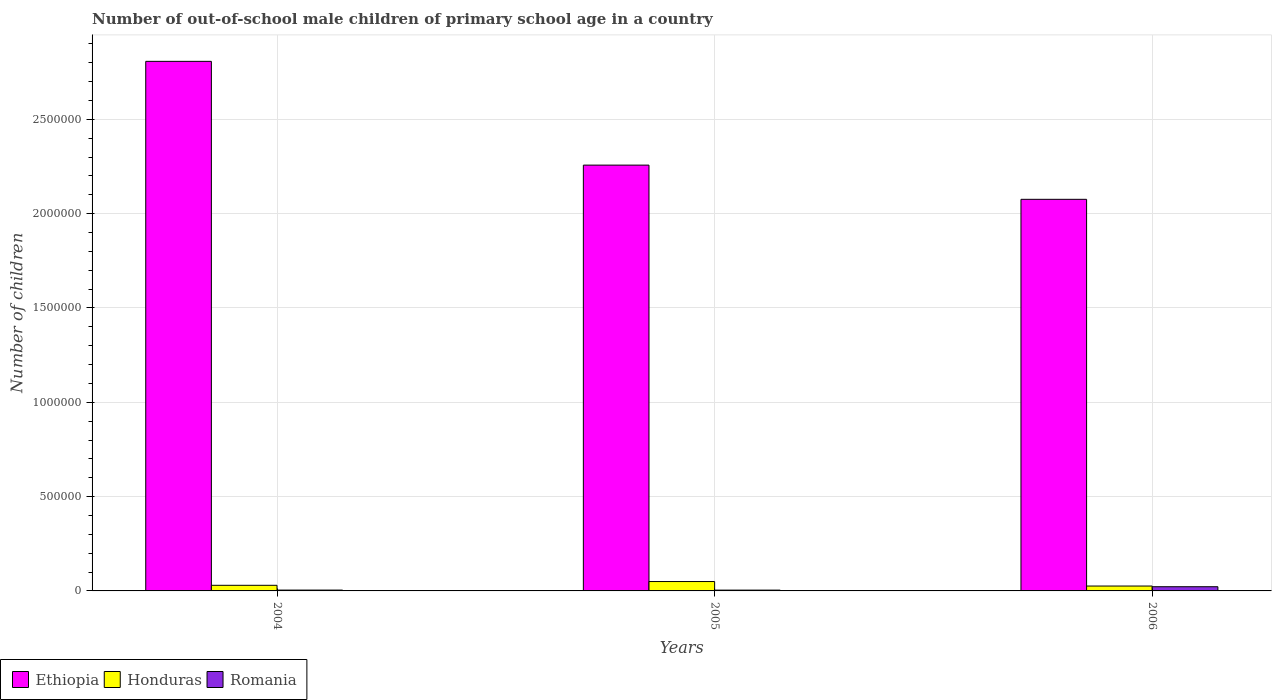How many different coloured bars are there?
Your answer should be compact. 3. Are the number of bars per tick equal to the number of legend labels?
Your answer should be compact. Yes. Are the number of bars on each tick of the X-axis equal?
Your answer should be very brief. Yes. How many bars are there on the 3rd tick from the left?
Provide a short and direct response. 3. How many bars are there on the 1st tick from the right?
Your response must be concise. 3. In how many cases, is the number of bars for a given year not equal to the number of legend labels?
Make the answer very short. 0. What is the number of out-of-school male children in Romania in 2005?
Give a very brief answer. 4225. Across all years, what is the maximum number of out-of-school male children in Honduras?
Make the answer very short. 4.97e+04. Across all years, what is the minimum number of out-of-school male children in Romania?
Your answer should be compact. 4225. In which year was the number of out-of-school male children in Honduras maximum?
Give a very brief answer. 2005. What is the total number of out-of-school male children in Ethiopia in the graph?
Provide a short and direct response. 7.14e+06. What is the difference between the number of out-of-school male children in Ethiopia in 2004 and that in 2006?
Make the answer very short. 7.31e+05. What is the difference between the number of out-of-school male children in Romania in 2005 and the number of out-of-school male children in Ethiopia in 2004?
Provide a short and direct response. -2.80e+06. What is the average number of out-of-school male children in Romania per year?
Give a very brief answer. 1.03e+04. In the year 2006, what is the difference between the number of out-of-school male children in Romania and number of out-of-school male children in Ethiopia?
Give a very brief answer. -2.05e+06. In how many years, is the number of out-of-school male children in Honduras greater than 700000?
Ensure brevity in your answer.  0. What is the ratio of the number of out-of-school male children in Ethiopia in 2004 to that in 2005?
Ensure brevity in your answer.  1.24. Is the number of out-of-school male children in Romania in 2004 less than that in 2005?
Your answer should be compact. No. What is the difference between the highest and the second highest number of out-of-school male children in Honduras?
Offer a very short reply. 1.99e+04. What is the difference between the highest and the lowest number of out-of-school male children in Romania?
Make the answer very short. 1.80e+04. In how many years, is the number of out-of-school male children in Ethiopia greater than the average number of out-of-school male children in Ethiopia taken over all years?
Keep it short and to the point. 1. Is the sum of the number of out-of-school male children in Ethiopia in 2004 and 2006 greater than the maximum number of out-of-school male children in Honduras across all years?
Keep it short and to the point. Yes. What does the 3rd bar from the left in 2004 represents?
Keep it short and to the point. Romania. What does the 2nd bar from the right in 2004 represents?
Give a very brief answer. Honduras. How many bars are there?
Make the answer very short. 9. How many years are there in the graph?
Give a very brief answer. 3. What is the difference between two consecutive major ticks on the Y-axis?
Offer a very short reply. 5.00e+05. Are the values on the major ticks of Y-axis written in scientific E-notation?
Make the answer very short. No. Does the graph contain grids?
Give a very brief answer. Yes. How are the legend labels stacked?
Ensure brevity in your answer.  Horizontal. What is the title of the graph?
Make the answer very short. Number of out-of-school male children of primary school age in a country. Does "Nepal" appear as one of the legend labels in the graph?
Ensure brevity in your answer.  No. What is the label or title of the Y-axis?
Your answer should be very brief. Number of children. What is the Number of children in Ethiopia in 2004?
Offer a terse response. 2.81e+06. What is the Number of children of Honduras in 2004?
Make the answer very short. 2.98e+04. What is the Number of children in Romania in 2004?
Make the answer very short. 4400. What is the Number of children in Ethiopia in 2005?
Keep it short and to the point. 2.26e+06. What is the Number of children in Honduras in 2005?
Provide a short and direct response. 4.97e+04. What is the Number of children of Romania in 2005?
Offer a very short reply. 4225. What is the Number of children in Ethiopia in 2006?
Give a very brief answer. 2.08e+06. What is the Number of children in Honduras in 2006?
Provide a short and direct response. 2.59e+04. What is the Number of children of Romania in 2006?
Keep it short and to the point. 2.22e+04. Across all years, what is the maximum Number of children of Ethiopia?
Your answer should be very brief. 2.81e+06. Across all years, what is the maximum Number of children of Honduras?
Your answer should be compact. 4.97e+04. Across all years, what is the maximum Number of children of Romania?
Keep it short and to the point. 2.22e+04. Across all years, what is the minimum Number of children of Ethiopia?
Offer a very short reply. 2.08e+06. Across all years, what is the minimum Number of children in Honduras?
Offer a very short reply. 2.59e+04. Across all years, what is the minimum Number of children in Romania?
Keep it short and to the point. 4225. What is the total Number of children of Ethiopia in the graph?
Give a very brief answer. 7.14e+06. What is the total Number of children of Honduras in the graph?
Your response must be concise. 1.05e+05. What is the total Number of children in Romania in the graph?
Your response must be concise. 3.08e+04. What is the difference between the Number of children in Ethiopia in 2004 and that in 2005?
Ensure brevity in your answer.  5.50e+05. What is the difference between the Number of children of Honduras in 2004 and that in 2005?
Provide a succinct answer. -1.99e+04. What is the difference between the Number of children of Romania in 2004 and that in 2005?
Offer a terse response. 175. What is the difference between the Number of children in Ethiopia in 2004 and that in 2006?
Make the answer very short. 7.31e+05. What is the difference between the Number of children of Honduras in 2004 and that in 2006?
Offer a terse response. 3923. What is the difference between the Number of children of Romania in 2004 and that in 2006?
Provide a succinct answer. -1.78e+04. What is the difference between the Number of children in Ethiopia in 2005 and that in 2006?
Provide a short and direct response. 1.81e+05. What is the difference between the Number of children of Honduras in 2005 and that in 2006?
Keep it short and to the point. 2.39e+04. What is the difference between the Number of children in Romania in 2005 and that in 2006?
Your answer should be compact. -1.80e+04. What is the difference between the Number of children of Ethiopia in 2004 and the Number of children of Honduras in 2005?
Your response must be concise. 2.76e+06. What is the difference between the Number of children in Ethiopia in 2004 and the Number of children in Romania in 2005?
Provide a short and direct response. 2.80e+06. What is the difference between the Number of children in Honduras in 2004 and the Number of children in Romania in 2005?
Your answer should be compact. 2.56e+04. What is the difference between the Number of children in Ethiopia in 2004 and the Number of children in Honduras in 2006?
Your answer should be very brief. 2.78e+06. What is the difference between the Number of children of Ethiopia in 2004 and the Number of children of Romania in 2006?
Your response must be concise. 2.79e+06. What is the difference between the Number of children of Honduras in 2004 and the Number of children of Romania in 2006?
Your response must be concise. 7571. What is the difference between the Number of children of Ethiopia in 2005 and the Number of children of Honduras in 2006?
Offer a very short reply. 2.23e+06. What is the difference between the Number of children of Ethiopia in 2005 and the Number of children of Romania in 2006?
Keep it short and to the point. 2.24e+06. What is the difference between the Number of children in Honduras in 2005 and the Number of children in Romania in 2006?
Your response must be concise. 2.75e+04. What is the average Number of children of Ethiopia per year?
Your answer should be compact. 2.38e+06. What is the average Number of children in Honduras per year?
Your answer should be very brief. 3.51e+04. What is the average Number of children of Romania per year?
Ensure brevity in your answer.  1.03e+04. In the year 2004, what is the difference between the Number of children of Ethiopia and Number of children of Honduras?
Make the answer very short. 2.78e+06. In the year 2004, what is the difference between the Number of children of Ethiopia and Number of children of Romania?
Ensure brevity in your answer.  2.80e+06. In the year 2004, what is the difference between the Number of children of Honduras and Number of children of Romania?
Give a very brief answer. 2.54e+04. In the year 2005, what is the difference between the Number of children of Ethiopia and Number of children of Honduras?
Ensure brevity in your answer.  2.21e+06. In the year 2005, what is the difference between the Number of children in Ethiopia and Number of children in Romania?
Give a very brief answer. 2.25e+06. In the year 2005, what is the difference between the Number of children of Honduras and Number of children of Romania?
Ensure brevity in your answer.  4.55e+04. In the year 2006, what is the difference between the Number of children in Ethiopia and Number of children in Honduras?
Your answer should be very brief. 2.05e+06. In the year 2006, what is the difference between the Number of children of Ethiopia and Number of children of Romania?
Your answer should be very brief. 2.05e+06. In the year 2006, what is the difference between the Number of children of Honduras and Number of children of Romania?
Your answer should be very brief. 3648. What is the ratio of the Number of children of Ethiopia in 2004 to that in 2005?
Your response must be concise. 1.24. What is the ratio of the Number of children of Honduras in 2004 to that in 2005?
Give a very brief answer. 0.6. What is the ratio of the Number of children of Romania in 2004 to that in 2005?
Provide a short and direct response. 1.04. What is the ratio of the Number of children in Ethiopia in 2004 to that in 2006?
Your response must be concise. 1.35. What is the ratio of the Number of children of Honduras in 2004 to that in 2006?
Your answer should be very brief. 1.15. What is the ratio of the Number of children in Romania in 2004 to that in 2006?
Give a very brief answer. 0.2. What is the ratio of the Number of children in Ethiopia in 2005 to that in 2006?
Your response must be concise. 1.09. What is the ratio of the Number of children of Honduras in 2005 to that in 2006?
Provide a succinct answer. 1.92. What is the ratio of the Number of children of Romania in 2005 to that in 2006?
Your answer should be compact. 0.19. What is the difference between the highest and the second highest Number of children of Ethiopia?
Make the answer very short. 5.50e+05. What is the difference between the highest and the second highest Number of children of Honduras?
Keep it short and to the point. 1.99e+04. What is the difference between the highest and the second highest Number of children of Romania?
Your answer should be compact. 1.78e+04. What is the difference between the highest and the lowest Number of children of Ethiopia?
Provide a short and direct response. 7.31e+05. What is the difference between the highest and the lowest Number of children in Honduras?
Provide a succinct answer. 2.39e+04. What is the difference between the highest and the lowest Number of children in Romania?
Offer a terse response. 1.80e+04. 